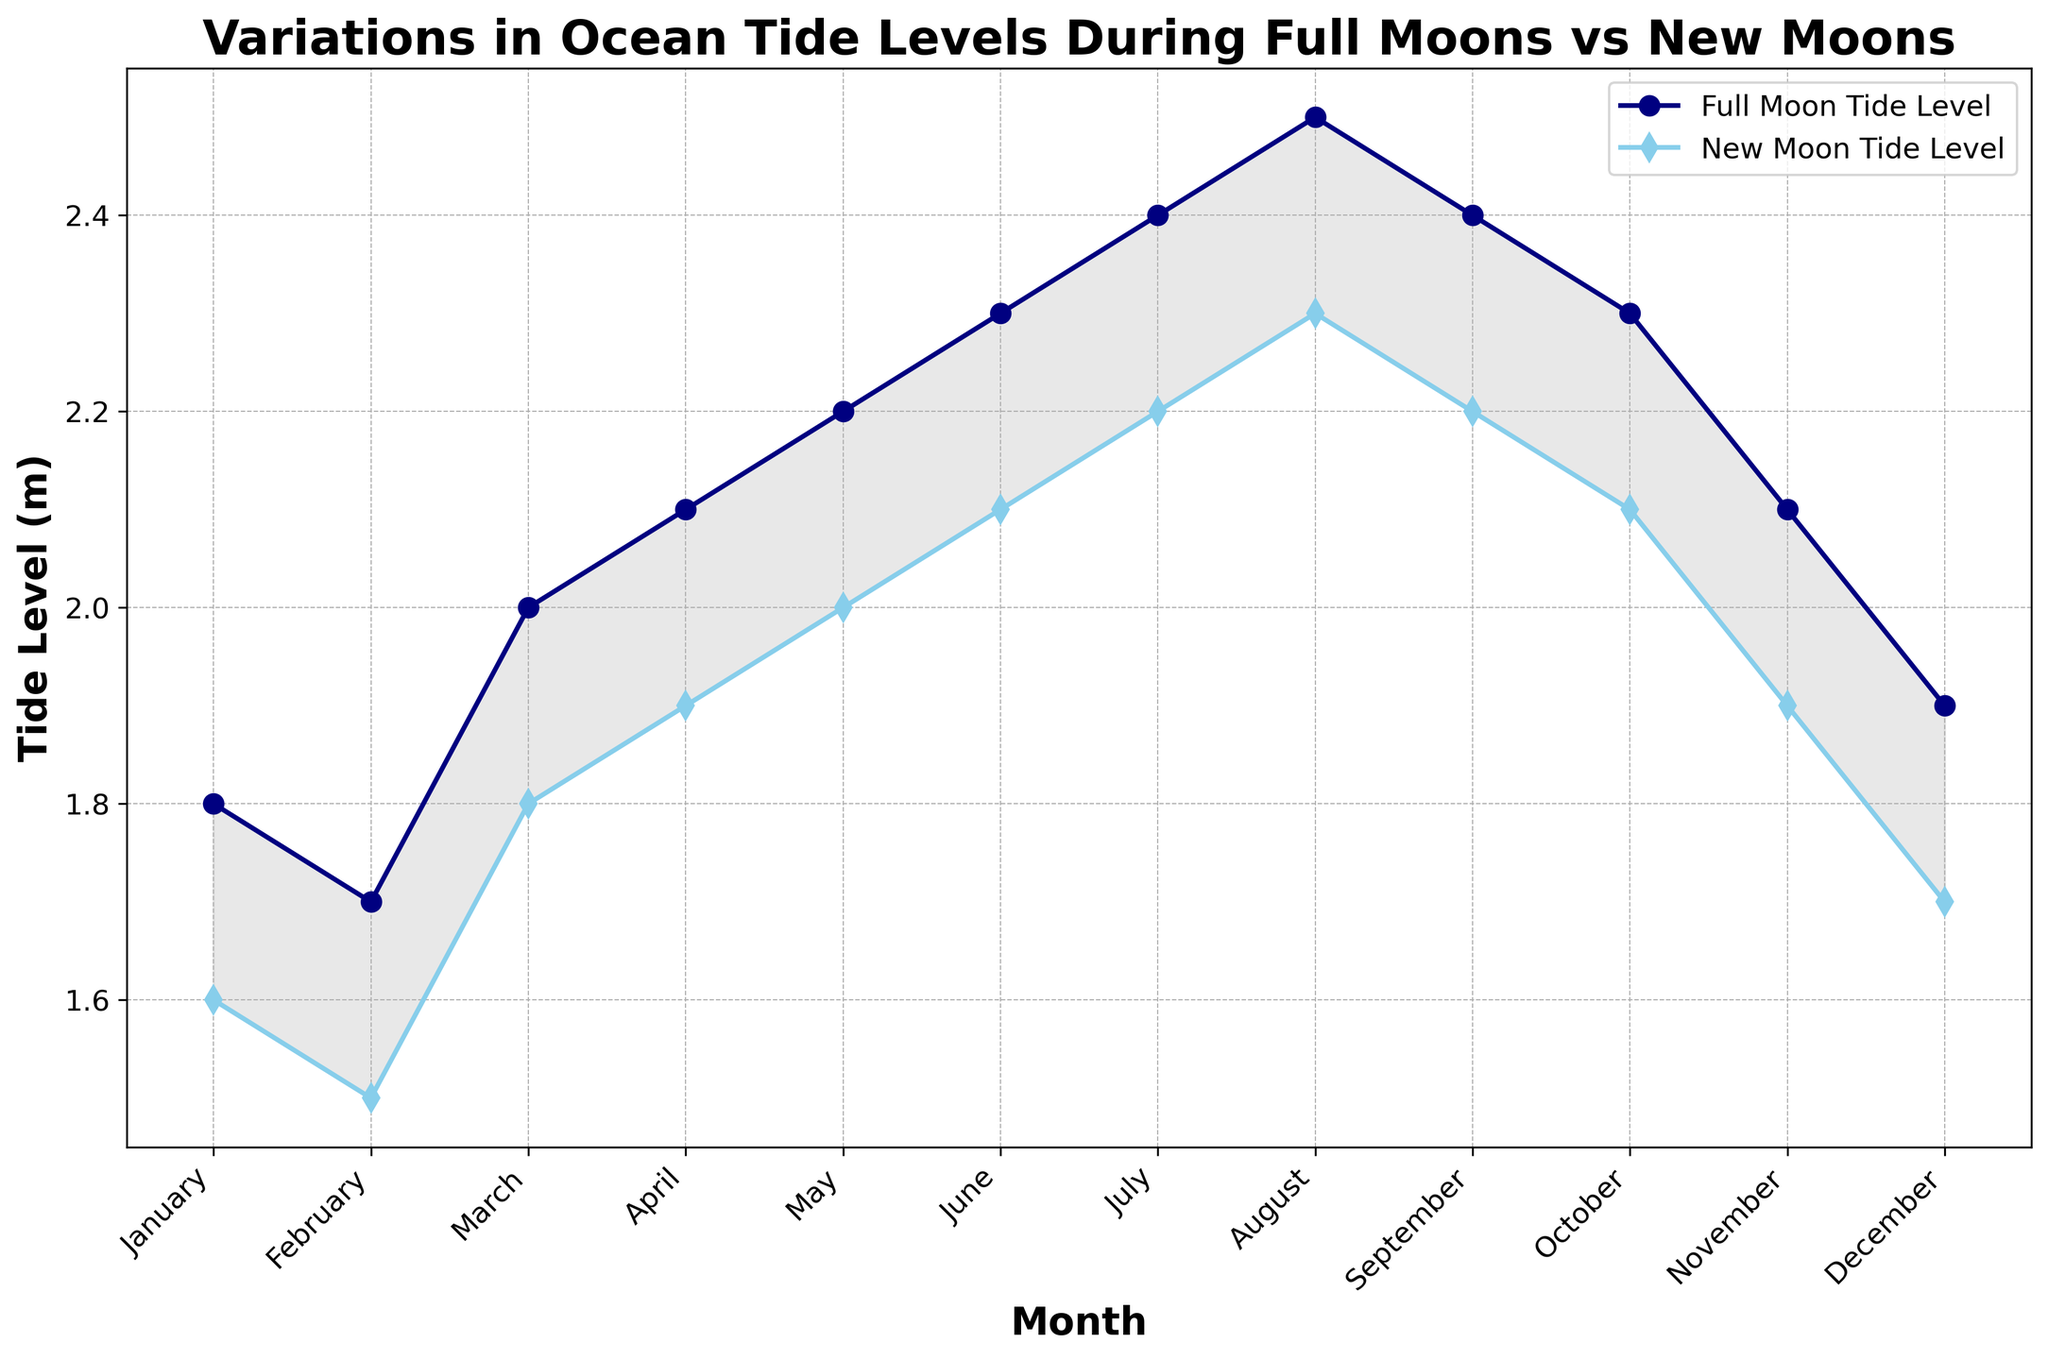What's the difference between the Full Moon Tide Level and the New Moon Tide Level in April? In April, the Full Moon Tide Level is 2.1 meters and the New Moon Tide Level is 1.9 meters. The difference is calculated as 2.1 - 1.9 = 0.2 meters.
Answer: 0.2 meters Which month has the highest tide level during the Full Moon? To find the month with the highest Full Moon Tide Level, observe the peaks for the Full Moon line. The highest tide level is 2.5 meters, which occurs in August.
Answer: August Is there any month where the Full Moon Tide Level is equal to 2.0 meters? By examining the Full Moon tide levels across the months, we see that the Full Moon Tide Level is exactly 2.0 meters in March.
Answer: March How does the Full Moon Tide Level in July compare to the New Moon Tide Level in the same month? In July, the Full Moon Tide Level is 2.4 meters and the New Moon Tide Level is 2.2 meters. The Full Moon Tide Level is therefore 0.2 meters higher than the New Moon Tide Level in July.
Answer: Full Moon Tide Level is 0.2 meters higher What is the average Full Moon Tide Level for the months of June, July, and August? The Full Moon Tide Levels for June, July, and August are 2.3, 2.4, and 2.5 meters respectively. The average is calculated as (2.3 + 2.4 + 2.5) / 3 = 2.4 meters.
Answer: 2.4 meters Which month shows the smallest difference between Full Moon and New Moon tide levels? To determine the smallest difference, calculate the difference for each month. The smallest difference is 0.2 meters, which occurs in May.
Answer: May During which month is the area between the Full Moon and New Moon tide levels the lightest (smallest difference in tide levels)? The smallest filling between the Full Moon and New Moon lines can be noticed in May, with a difference of 0.2 meters.
Answer: May How does the trend of Full Moon Tide Levels change from January to December? From January to December, the Full Moon Tide Level starts at 1.8 meters, gradually increases to a peak of 2.5 meters in August, and then decreases back to 1.9 meters in December.
Answer: Increases, peaks in August, then decreases In which month does the New Moon Tide Level reach its highest value? The highest New Moon Tide Level is 2.3 meters, which occurs in August.
Answer: August 